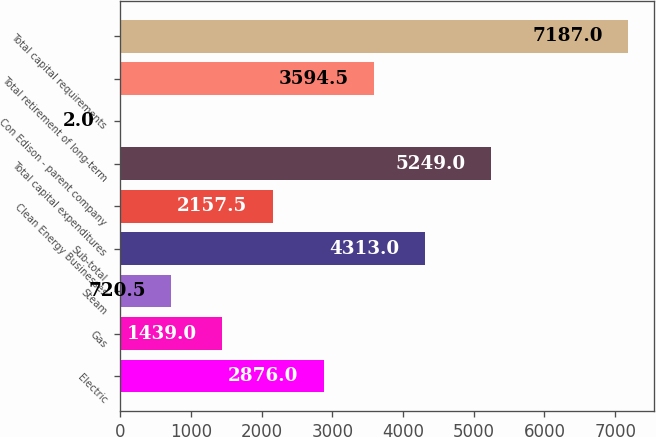<chart> <loc_0><loc_0><loc_500><loc_500><bar_chart><fcel>Electric<fcel>Gas<fcel>Steam<fcel>Sub-total<fcel>Clean Energy Businesses<fcel>Total capital expenditures<fcel>Con Edison - parent company<fcel>Total retirement of long-term<fcel>Total capital requirements<nl><fcel>2876<fcel>1439<fcel>720.5<fcel>4313<fcel>2157.5<fcel>5249<fcel>2<fcel>3594.5<fcel>7187<nl></chart> 